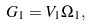<formula> <loc_0><loc_0><loc_500><loc_500>G _ { 1 } = V _ { 1 } \Omega _ { 1 } ,</formula> 